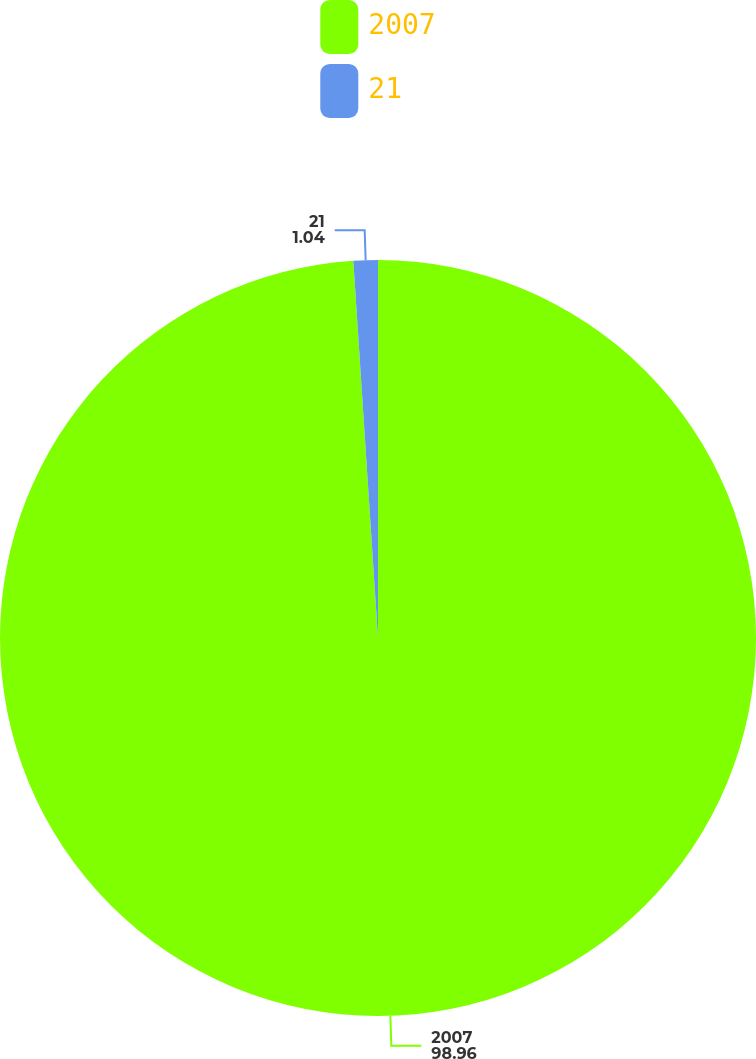Convert chart to OTSL. <chart><loc_0><loc_0><loc_500><loc_500><pie_chart><fcel>2007<fcel>21<nl><fcel>98.96%<fcel>1.04%<nl></chart> 